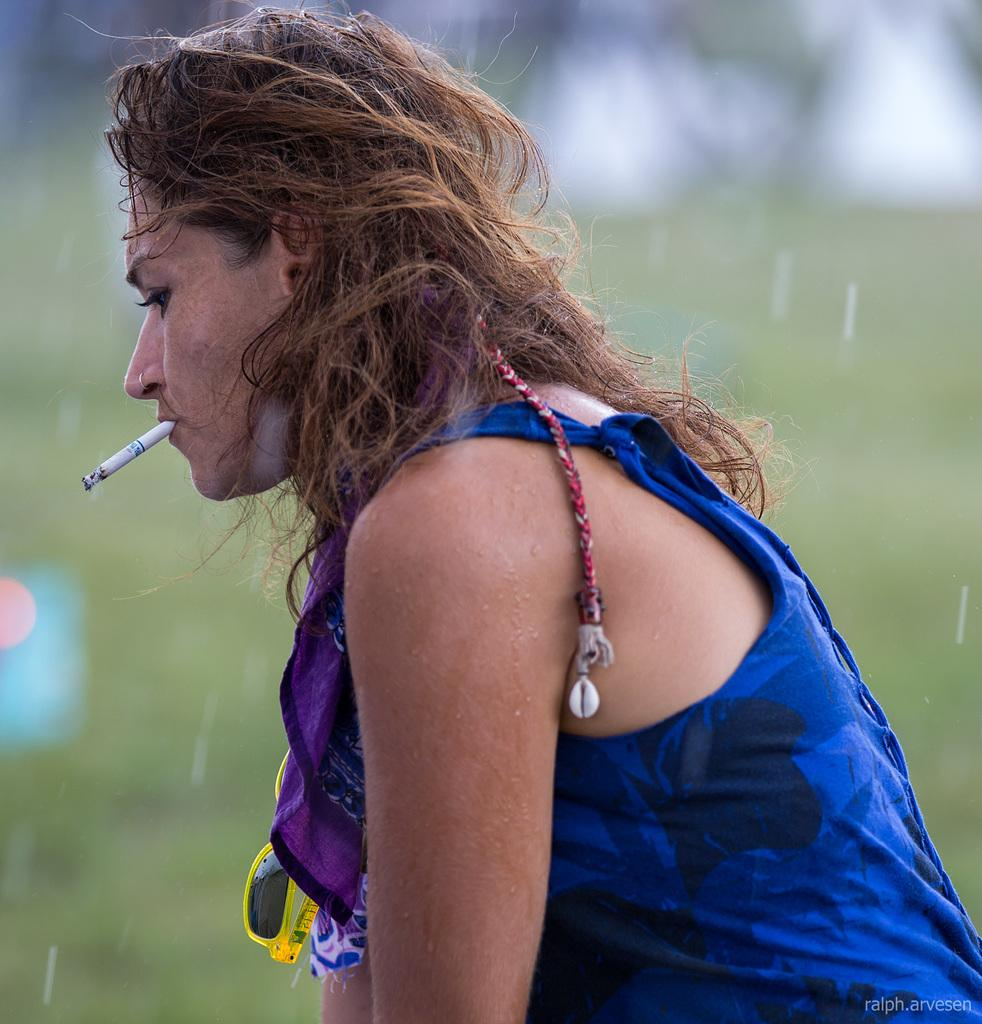Who is the main subject in the image? There is a woman in the image. What is the woman doing in the image? The woman is smoking. Can you describe the background of the image? The background of the image is blurry. What type of quill is the woman using to write in the image? There is no quill present in the image, and the woman is not writing. 